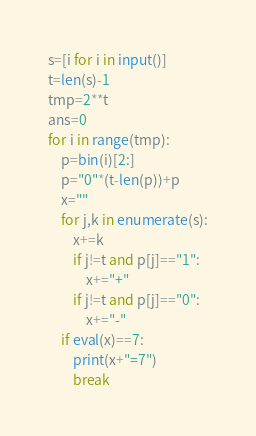Convert code to text. <code><loc_0><loc_0><loc_500><loc_500><_Python_>s=[i for i in input()]
t=len(s)-1
tmp=2**t
ans=0
for i in range(tmp):
    p=bin(i)[2:]
    p="0"*(t-len(p))+p
    x=""
    for j,k in enumerate(s):
        x+=k
        if j!=t and p[j]=="1":
            x+="+"
        if j!=t and p[j]=="0":
            x+="-"
    if eval(x)==7:
        print(x+"=7")
        break</code> 